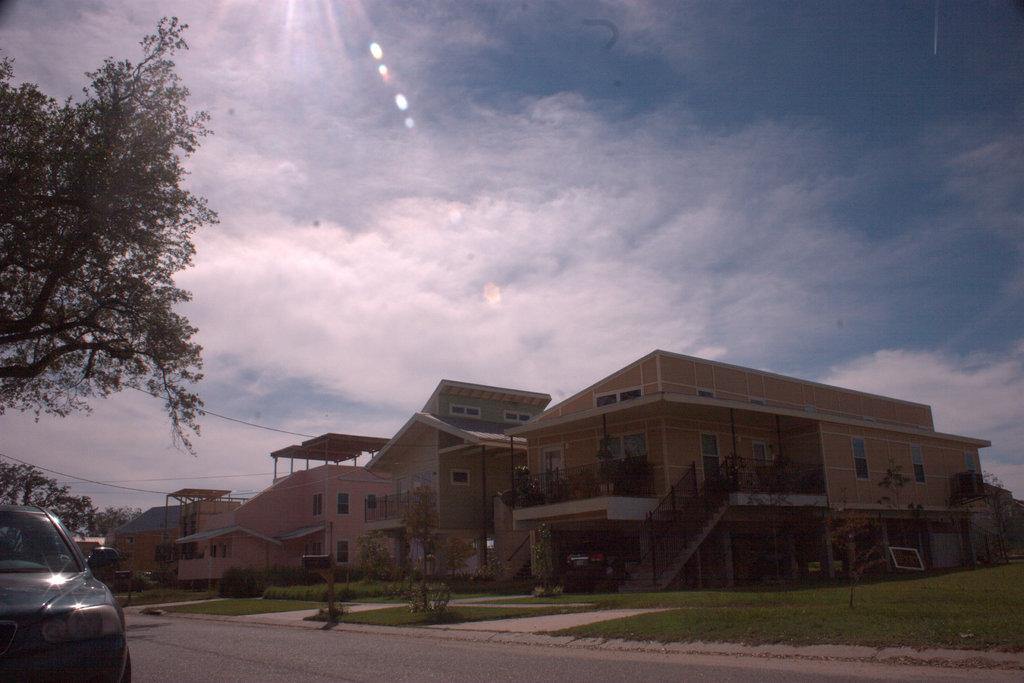What type of structures can be seen in the image? There are buildings in the image. Can you describe a specific architectural feature in the image? There is a staircase in the image, and railings are present. What material is used for the railings? The railings are made of metal, as metal rods are visible in the image. What type of vegetation can be seen in the image? There are trees, bushes, and houseplants visible in the image. Is there any transportation present in the image? Yes, a motor vehicle is on the road in the image. What is visible in the sky in the image? The sky is visible in the image, and clouds are present. What type of cattle can be seen grazing in the image? There is no cattle present in the image; it features buildings, a staircase, railings, trees, bushes, houseplants, a motor vehicle, cables, and a sky with clouds. What color is the shirt worn by the person in the image? There is no person present in the image, so it is not possible to determine the color of a shirt. 